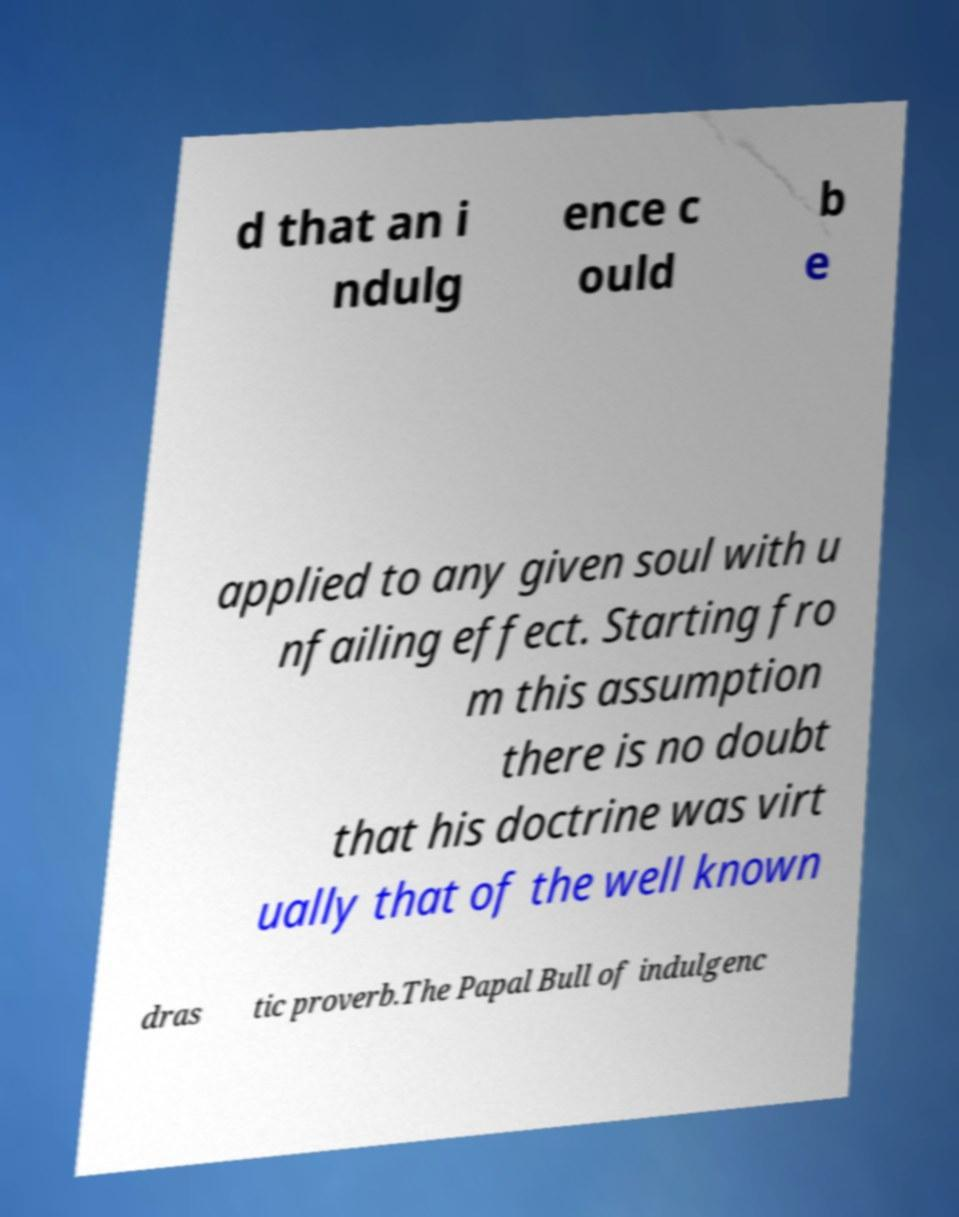What messages or text are displayed in this image? I need them in a readable, typed format. d that an i ndulg ence c ould b e applied to any given soul with u nfailing effect. Starting fro m this assumption there is no doubt that his doctrine was virt ually that of the well known dras tic proverb.The Papal Bull of indulgenc 